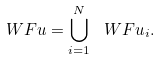Convert formula to latex. <formula><loc_0><loc_0><loc_500><loc_500>\ W F { u } = \bigcup _ { i = 1 } ^ { N } \ W F { u _ { i } } .</formula> 